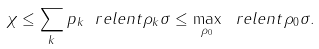Convert formula to latex. <formula><loc_0><loc_0><loc_500><loc_500>\chi \leq \sum _ { k } p _ { k } \ r e l e n t { \rho _ { k } } { \sigma } \leq \max _ { \rho _ { 0 } } \ r e l e n t { \rho _ { 0 } } { \sigma } .</formula> 